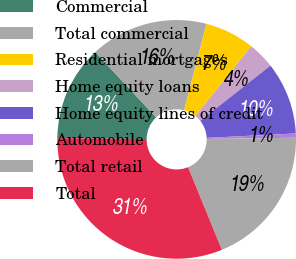<chart> <loc_0><loc_0><loc_500><loc_500><pie_chart><fcel>Commercial<fcel>Total commercial<fcel>Residential mortgages<fcel>Home equity loans<fcel>Home equity lines of credit<fcel>Automobile<fcel>Total retail<fcel>Total<nl><fcel>12.88%<fcel>15.96%<fcel>6.73%<fcel>3.65%<fcel>9.81%<fcel>0.57%<fcel>19.04%<fcel>31.36%<nl></chart> 